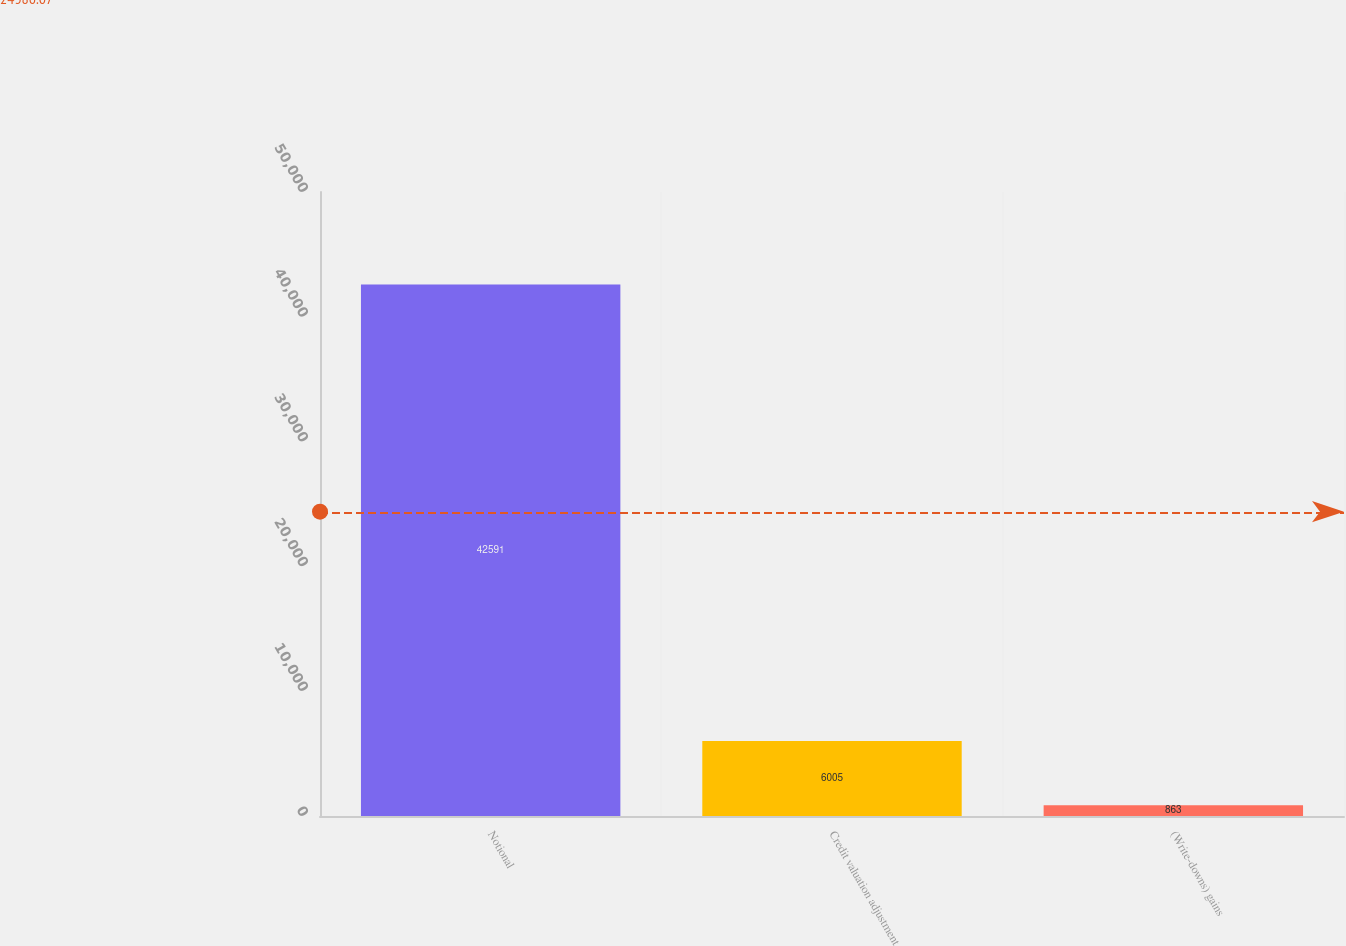Convert chart. <chart><loc_0><loc_0><loc_500><loc_500><bar_chart><fcel>Notional<fcel>Credit valuation adjustment<fcel>(Write-downs) gains<nl><fcel>42591<fcel>6005<fcel>863<nl></chart> 